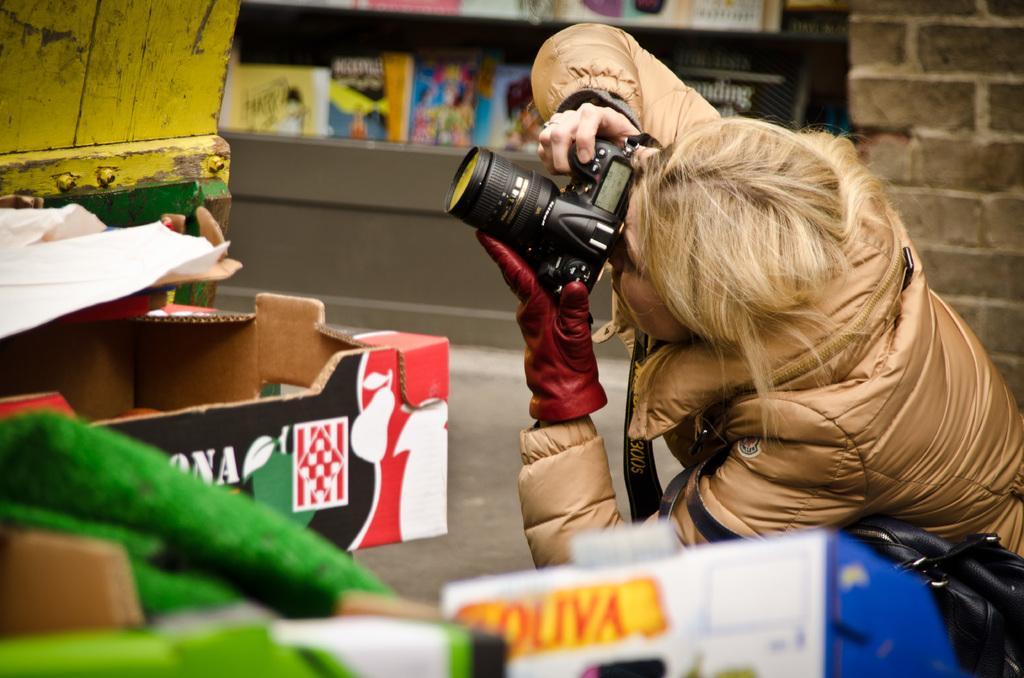Describe this image in one or two sentences. a woman is capturing a picture with her camera 